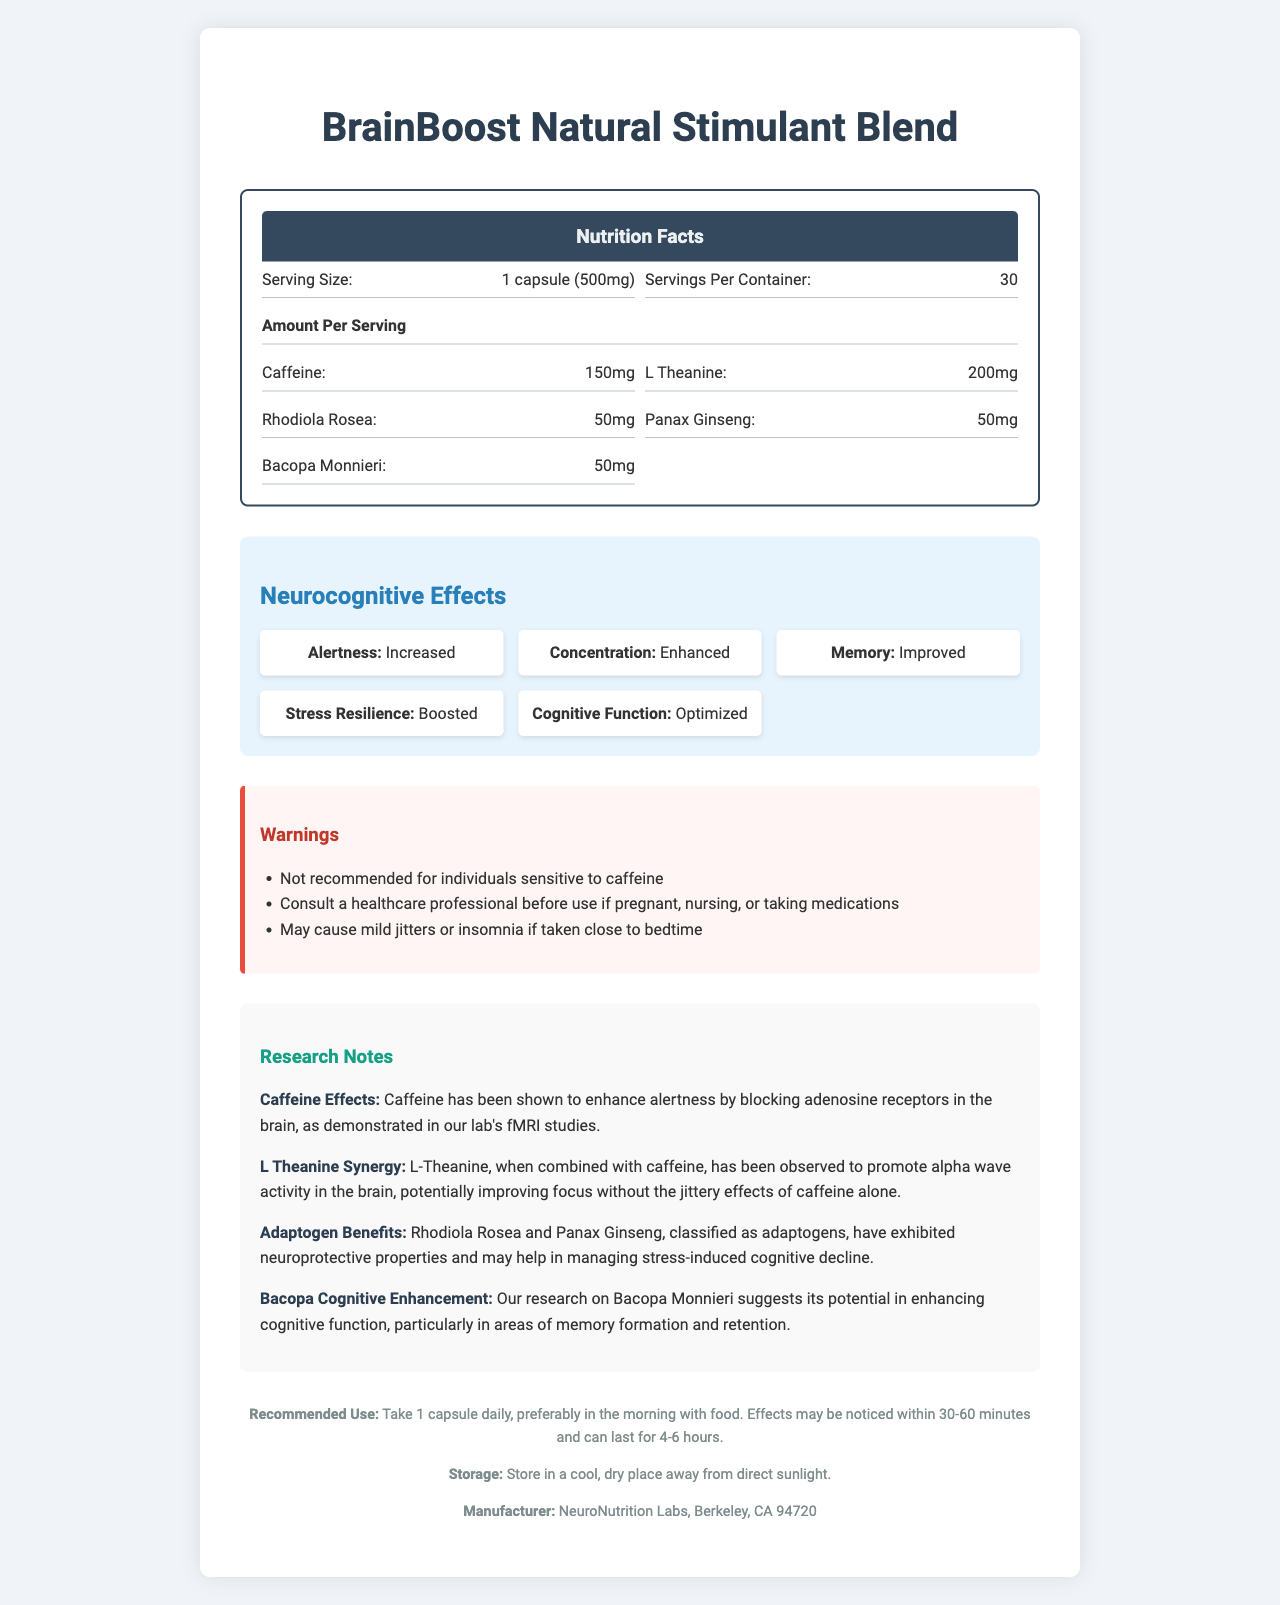what is the serving size of BrainBoost Natural Stimulant Blend? The serving size is clearly indicated in the first section of the nutrition label.
Answer: 1 capsule (500mg) how many servings are in one container of BrainBoost Natural Stimulant Blend? The document specifies that there are 30 servings per container in the second section.
Answer: 30 what is the amount of L-Theanine per serving? This information is listed under the "Amount Per Serving" section.
Answer: 200mg list two ingredients classified as adaptogens in BrainBoost Natural Stimulant Blend. These two ingredients are mentioned as adaptogens in the research notes section.
Answer: Rhodiola Rosea and Panax Ginseng what effects does Bacopa Monnieri have according to the research notes? The research notes provide detailed information on Bacopa Monnieri's cognitive enhancing properties.
Answer: Enhancing cognitive function, particularly in areas of memory formation and retention which ingredient from the blend may cause mild jitters or insomnia if taken close to bedtime? The warning section mentions that caffeine may cause jitters or insomnia if taken close to bedtime.
Answer: Caffeine cognitive_function has been described as which of the following in the Neurocognitive Effects section? A. Enhanced B. Boosted C. Optimized D. Improved The effect on cognitive function is listed as "Optimized" under the Neurocognitive Effects section.
Answer: C. Optimized which ingredient is sourced from green coffee beans? A. Rhodiola Rosea B. L-Theanine C. Caffeine D. Bacopa Monnieri The ingredients list specifies that caffeine is sourced from green coffee beans.
Answer: C. Caffeine should individuals sensitive to caffeine use BrainBoost Natural Stimulant Blend? The warning section clearly states that it is not recommended for individuals sensitive to caffeine.
Answer: No summarize the main purpose of the BrainBoost Natural Stimulant Blend document. The document comprehensively covers various aspects of the product, offering both practical usage instructions and scientific insights into its effects.
Answer: The document provides detailed information about the BrainBoost Natural Stimulant Blend, including its ingredients, nutritional content, and neurocognitive effects. It also includes warnings, research notes on the ingredients, recommended use, storage conditions, and manufacturer details. does the document establish the percent daily value for caffeine? The percent daily value for caffeine and other ingredients is marked as "Not established."
Answer: No where is NeuroNutrition Labs located? The location of the manufacturer is listed at the bottom of the document.
Answer: Berkeley, CA 94720 how long after taking BrainBoost Natural Stimulant Blend can effects be noticed? The recommended use section mentions that effects may be noticed within 30-60 minutes.
Answer: 30-60 minutes is there information on the combined effect of L-Theanine and caffeine? The research notes explain that L-Theanine, when combined with caffeine, promotes alpha wave activity in the brain.
Answer: Yes explain the importance of Rhodiola Rosea and Panax Ginseng according to the document. The research notes detail the adaptogenic benefits of Rhodiola Rosea and Panax Ginseng, emphasizing their role in brain health and stress management.
Answer: Both are classified as adaptogens and have exhibited neuroprotective properties, potentially helping in managing stress-induced cognitive decline. what is the exact city and state where the manufacturer is located? The document specifies that NeuroNutrition Labs is based in Berkeley, CA.
Answer: Berkeley, CA is the percent daily value for caffeine established? The document states "not established" for the percent daily value, meaning it is not determined based on the document itself.
Answer: Not enough information what should you do if you are taking medications and want to use BrainBoost Natural Stimulant Blend? According to the warning section, it is recommended to consult a healthcare professional in such cases.
Answer: Consult a healthcare professional 